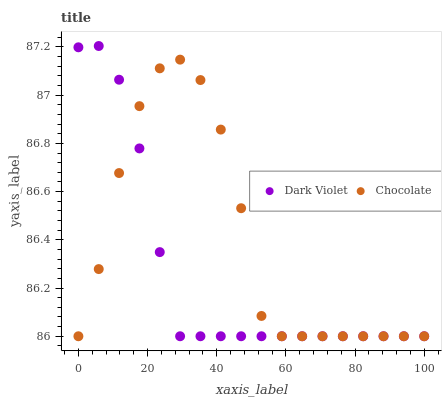Does Dark Violet have the minimum area under the curve?
Answer yes or no. Yes. Does Chocolate have the maximum area under the curve?
Answer yes or no. Yes. Does Chocolate have the minimum area under the curve?
Answer yes or no. No. Is Dark Violet the smoothest?
Answer yes or no. Yes. Is Chocolate the roughest?
Answer yes or no. Yes. Is Chocolate the smoothest?
Answer yes or no. No. Does Dark Violet have the lowest value?
Answer yes or no. Yes. Does Dark Violet have the highest value?
Answer yes or no. Yes. Does Chocolate have the highest value?
Answer yes or no. No. Does Chocolate intersect Dark Violet?
Answer yes or no. Yes. Is Chocolate less than Dark Violet?
Answer yes or no. No. Is Chocolate greater than Dark Violet?
Answer yes or no. No. 